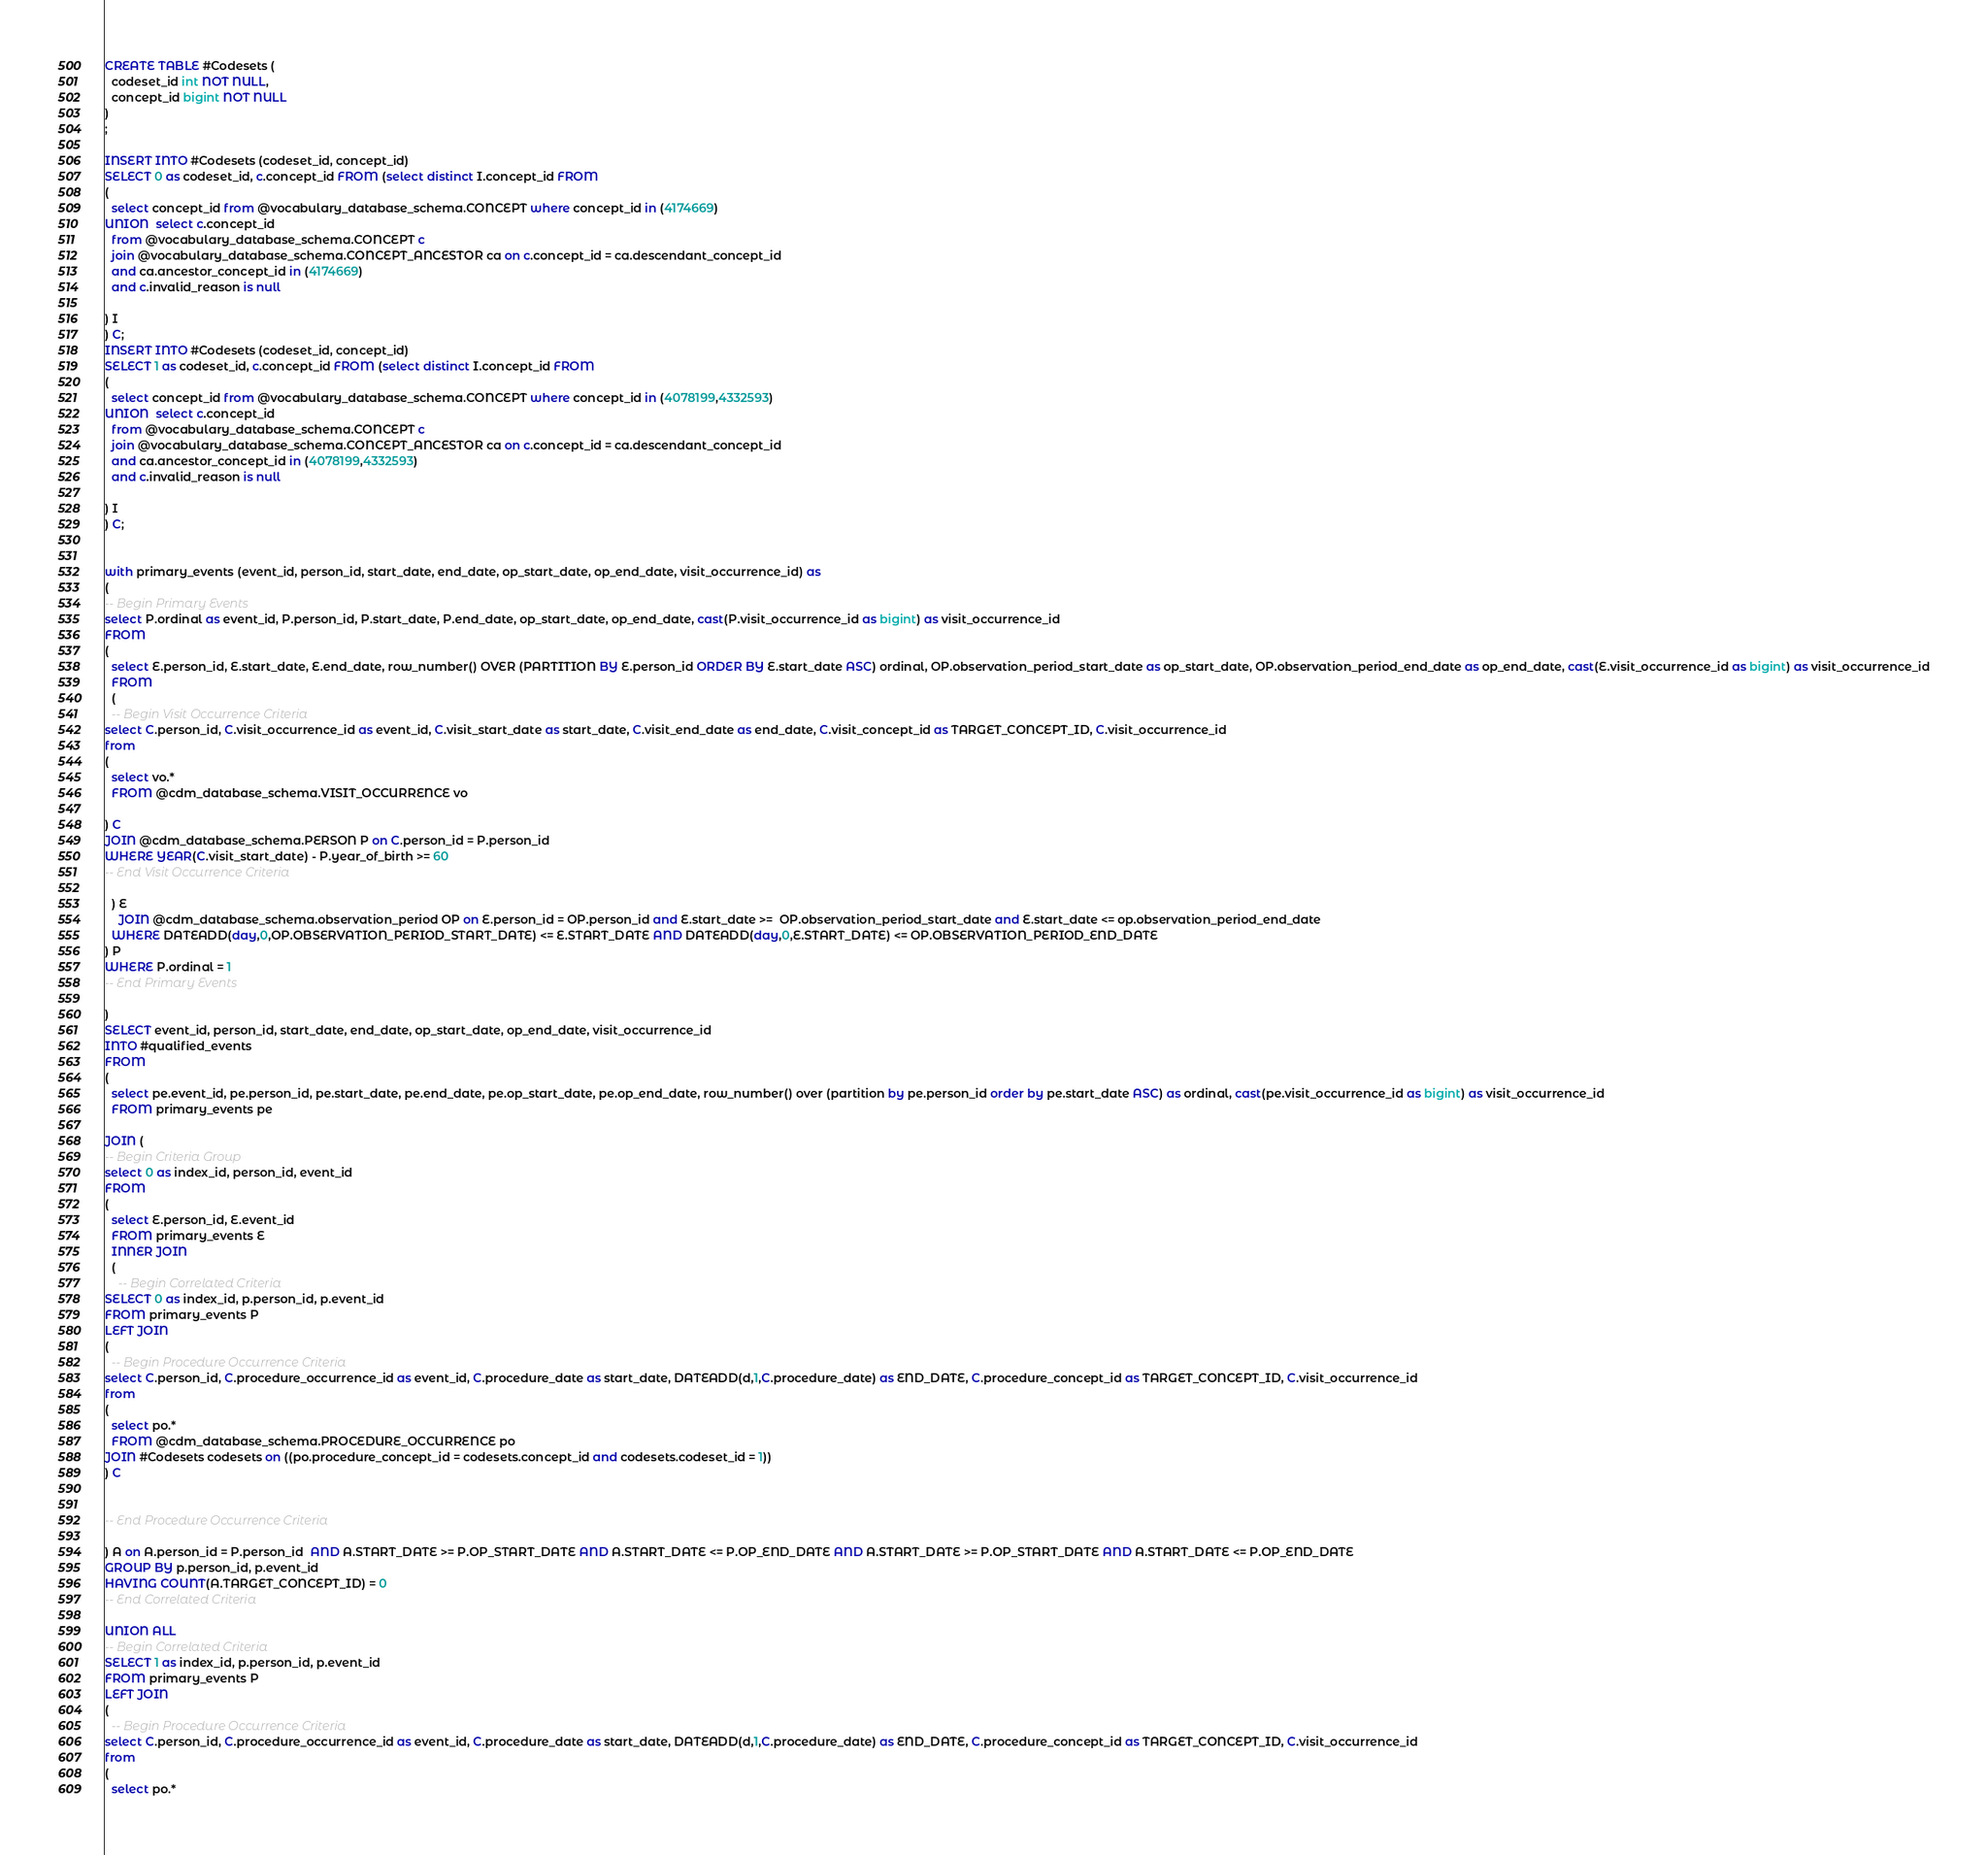<code> <loc_0><loc_0><loc_500><loc_500><_SQL_>CREATE TABLE #Codesets (
  codeset_id int NOT NULL,
  concept_id bigint NOT NULL
)
;

INSERT INTO #Codesets (codeset_id, concept_id)
SELECT 0 as codeset_id, c.concept_id FROM (select distinct I.concept_id FROM
( 
  select concept_id from @vocabulary_database_schema.CONCEPT where concept_id in (4174669)
UNION  select c.concept_id
  from @vocabulary_database_schema.CONCEPT c
  join @vocabulary_database_schema.CONCEPT_ANCESTOR ca on c.concept_id = ca.descendant_concept_id
  and ca.ancestor_concept_id in (4174669)
  and c.invalid_reason is null

) I
) C;
INSERT INTO #Codesets (codeset_id, concept_id)
SELECT 1 as codeset_id, c.concept_id FROM (select distinct I.concept_id FROM
( 
  select concept_id from @vocabulary_database_schema.CONCEPT where concept_id in (4078199,4332593)
UNION  select c.concept_id
  from @vocabulary_database_schema.CONCEPT c
  join @vocabulary_database_schema.CONCEPT_ANCESTOR ca on c.concept_id = ca.descendant_concept_id
  and ca.ancestor_concept_id in (4078199,4332593)
  and c.invalid_reason is null

) I
) C;


with primary_events (event_id, person_id, start_date, end_date, op_start_date, op_end_date, visit_occurrence_id) as
(
-- Begin Primary Events
select P.ordinal as event_id, P.person_id, P.start_date, P.end_date, op_start_date, op_end_date, cast(P.visit_occurrence_id as bigint) as visit_occurrence_id
FROM
(
  select E.person_id, E.start_date, E.end_date, row_number() OVER (PARTITION BY E.person_id ORDER BY E.start_date ASC) ordinal, OP.observation_period_start_date as op_start_date, OP.observation_period_end_date as op_end_date, cast(E.visit_occurrence_id as bigint) as visit_occurrence_id
  FROM 
  (
  -- Begin Visit Occurrence Criteria
select C.person_id, C.visit_occurrence_id as event_id, C.visit_start_date as start_date, C.visit_end_date as end_date, C.visit_concept_id as TARGET_CONCEPT_ID, C.visit_occurrence_id
from 
(
  select vo.* 
  FROM @cdm_database_schema.VISIT_OCCURRENCE vo

) C
JOIN @cdm_database_schema.PERSON P on C.person_id = P.person_id
WHERE YEAR(C.visit_start_date) - P.year_of_birth >= 60
-- End Visit Occurrence Criteria

  ) E
	JOIN @cdm_database_schema.observation_period OP on E.person_id = OP.person_id and E.start_date >=  OP.observation_period_start_date and E.start_date <= op.observation_period_end_date
  WHERE DATEADD(day,0,OP.OBSERVATION_PERIOD_START_DATE) <= E.START_DATE AND DATEADD(day,0,E.START_DATE) <= OP.OBSERVATION_PERIOD_END_DATE
) P
WHERE P.ordinal = 1
-- End Primary Events

)
SELECT event_id, person_id, start_date, end_date, op_start_date, op_end_date, visit_occurrence_id
INTO #qualified_events
FROM 
(
  select pe.event_id, pe.person_id, pe.start_date, pe.end_date, pe.op_start_date, pe.op_end_date, row_number() over (partition by pe.person_id order by pe.start_date ASC) as ordinal, cast(pe.visit_occurrence_id as bigint) as visit_occurrence_id
  FROM primary_events pe
  
JOIN (
-- Begin Criteria Group
select 0 as index_id, person_id, event_id
FROM
(
  select E.person_id, E.event_id 
  FROM primary_events E
  INNER JOIN
  (
    -- Begin Correlated Criteria
SELECT 0 as index_id, p.person_id, p.event_id
FROM primary_events P
LEFT JOIN
(
  -- Begin Procedure Occurrence Criteria
select C.person_id, C.procedure_occurrence_id as event_id, C.procedure_date as start_date, DATEADD(d,1,C.procedure_date) as END_DATE, C.procedure_concept_id as TARGET_CONCEPT_ID, C.visit_occurrence_id
from 
(
  select po.* 
  FROM @cdm_database_schema.PROCEDURE_OCCURRENCE po
JOIN #Codesets codesets on ((po.procedure_concept_id = codesets.concept_id and codesets.codeset_id = 1))
) C


-- End Procedure Occurrence Criteria

) A on A.person_id = P.person_id  AND A.START_DATE >= P.OP_START_DATE AND A.START_DATE <= P.OP_END_DATE AND A.START_DATE >= P.OP_START_DATE AND A.START_DATE <= P.OP_END_DATE
GROUP BY p.person_id, p.event_id
HAVING COUNT(A.TARGET_CONCEPT_ID) = 0
-- End Correlated Criteria

UNION ALL
-- Begin Correlated Criteria
SELECT 1 as index_id, p.person_id, p.event_id
FROM primary_events P
LEFT JOIN
(
  -- Begin Procedure Occurrence Criteria
select C.person_id, C.procedure_occurrence_id as event_id, C.procedure_date as start_date, DATEADD(d,1,C.procedure_date) as END_DATE, C.procedure_concept_id as TARGET_CONCEPT_ID, C.visit_occurrence_id
from 
(
  select po.* </code> 